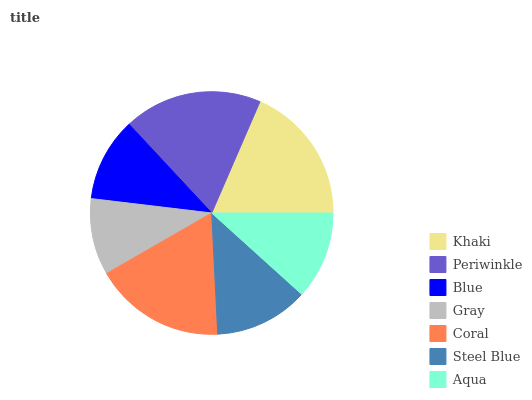Is Gray the minimum?
Answer yes or no. Yes. Is Khaki the maximum?
Answer yes or no. Yes. Is Periwinkle the minimum?
Answer yes or no. No. Is Periwinkle the maximum?
Answer yes or no. No. Is Khaki greater than Periwinkle?
Answer yes or no. Yes. Is Periwinkle less than Khaki?
Answer yes or no. Yes. Is Periwinkle greater than Khaki?
Answer yes or no. No. Is Khaki less than Periwinkle?
Answer yes or no. No. Is Steel Blue the high median?
Answer yes or no. Yes. Is Steel Blue the low median?
Answer yes or no. Yes. Is Gray the high median?
Answer yes or no. No. Is Periwinkle the low median?
Answer yes or no. No. 